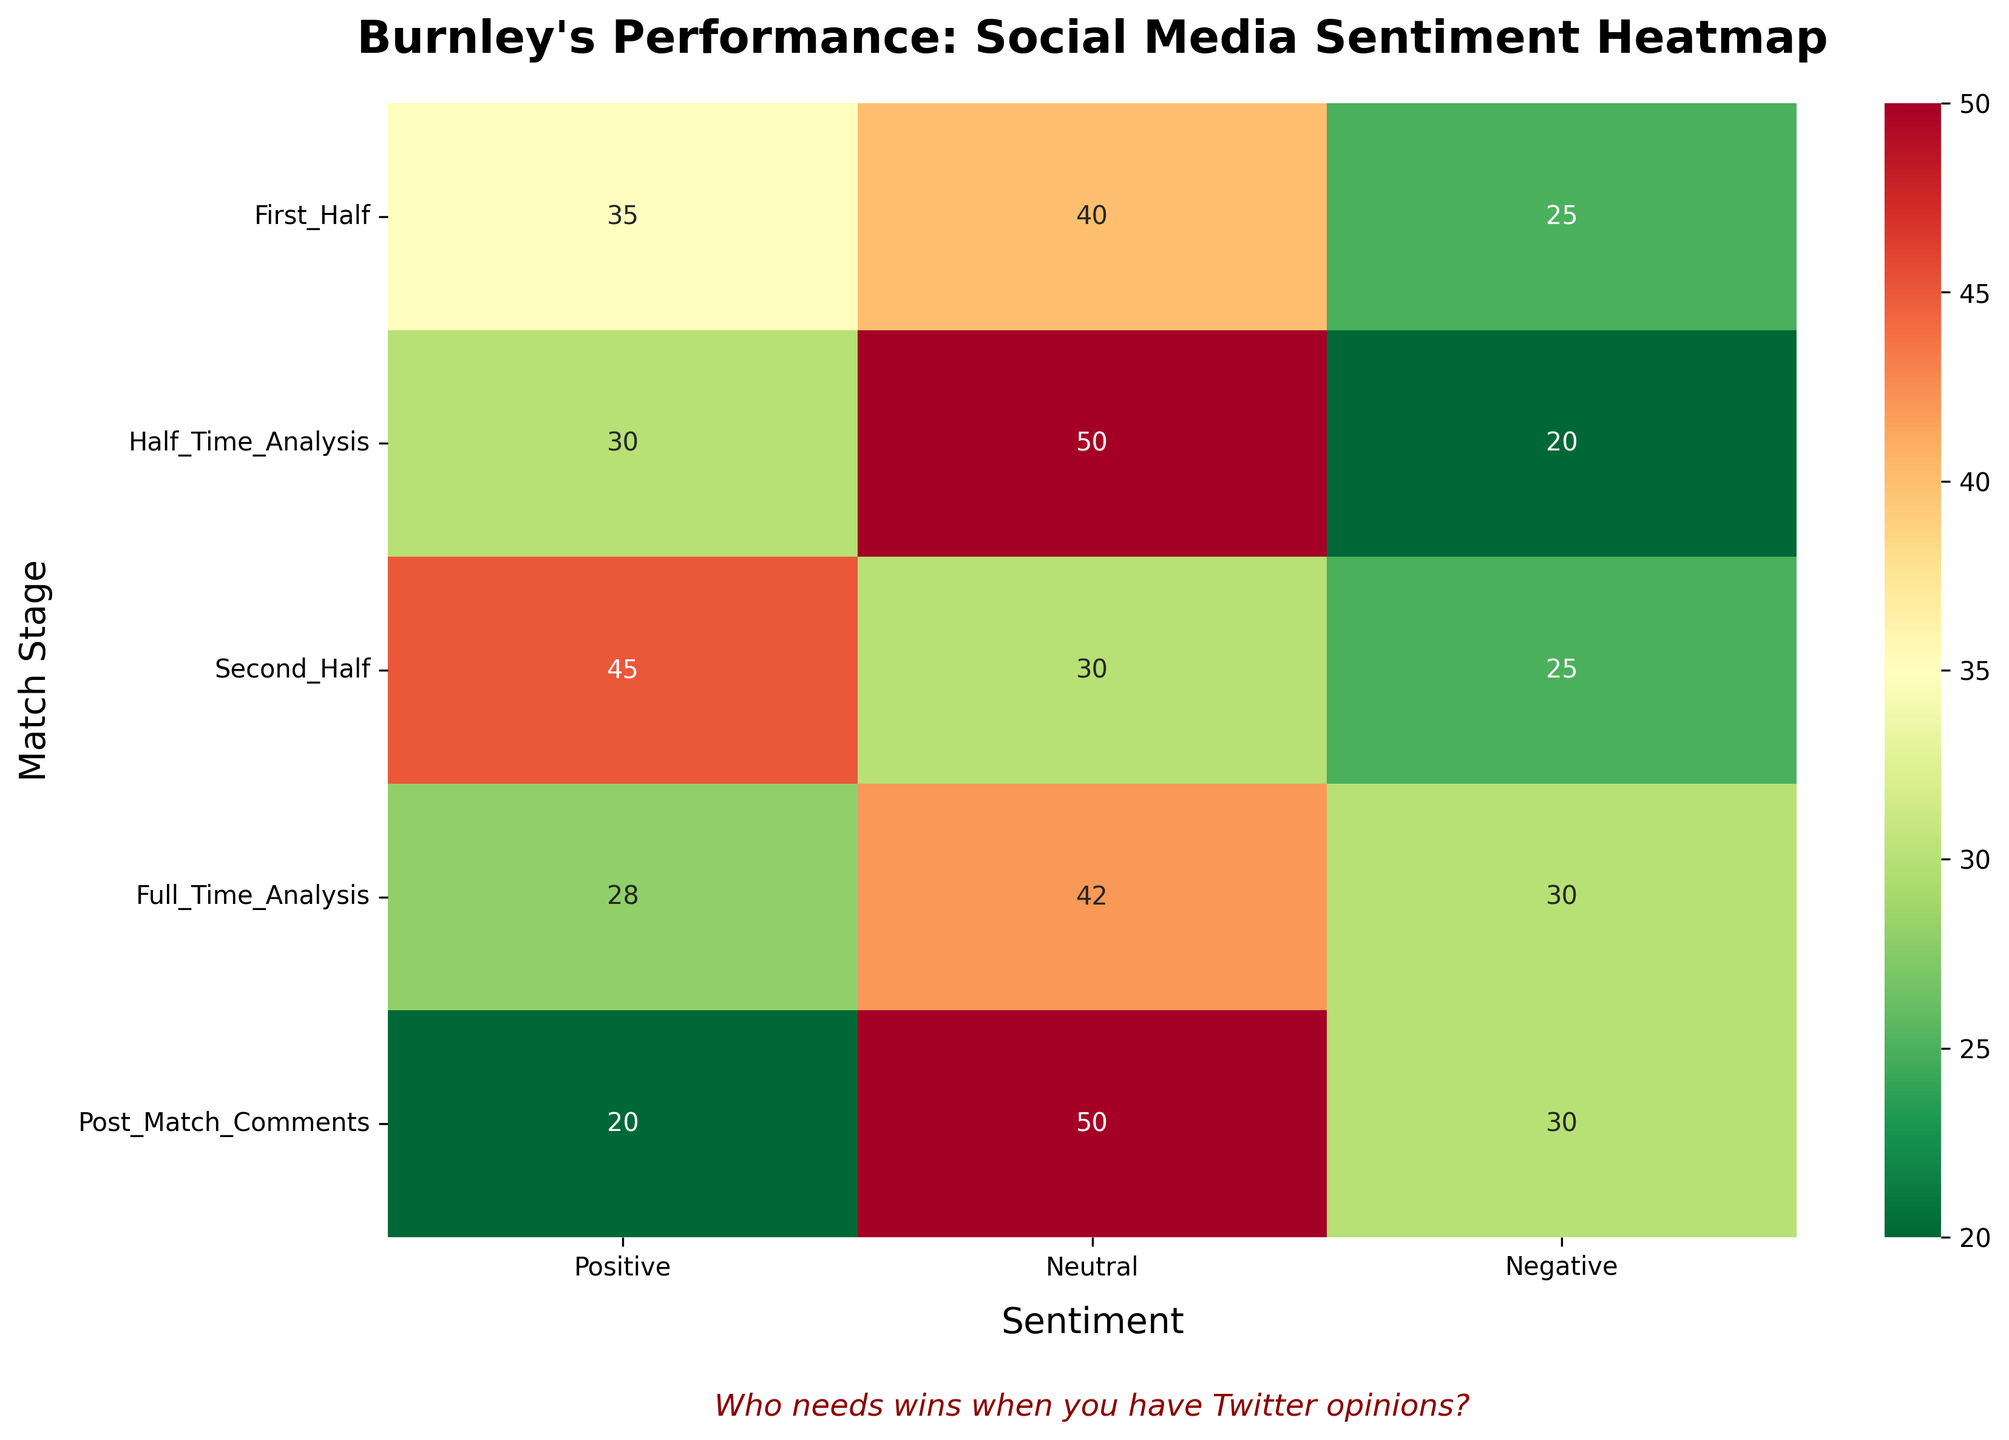What's the title of the heatmap? Look at the top of the heatmap where the title is displayed.
Answer: Burnley's Performance: Social Media Sentiment Heatmap What are the different match stages included in the heatmap? Look at the y-axis labels to see the different match stages listed.
Answer: First Half, Half Time Analysis, Second Half, Full Time Analysis, Post Match Comments Which match stage has the highest positive sentiment? Look at the values in the "Positive" column and find the highest value.
Answer: Second Half What is the total percentage of neutral sentiment during Full Time Analysis and Post Match Comments? Add the neutral sentiment percentages for Full Time Analysis (42) and Post Match Comments (50).
Answer: 92 In which match stage does Burnley receive the most negative sentiment? Look at the values in the "Negative" column and find the highest value.
Answer: Full Time Analysis and Post Match Comments (tie) Compare the positive sentiment during the First Half and Second Half. Which one is higher? Compare the positive sentiment percentages: First Half (35) and Second Half (45).
Answer: Second Half Which match stage has the lowest positive sentiment? Look at the values in the "Positive" column and find the lowest value.
Answer: Post Match Comments What is the difference in neutral sentiment between the Second Half and First Half? Subtract the neutral sentiment percentage of the First Half (40) from the Second Half (30).
Answer: -10 What color range is used in the heatmap to represent the sentiment values? Observe the color gradient from the lowest sentiment to the highest sentiment.
Answer: RdYlGn_r (red to green, reversed) What sarcastic comment is included in the heatmap? Look below the main part of the heatmap for any textual comments included.
Answer: Who needs wins when you have Twitter opinions? 